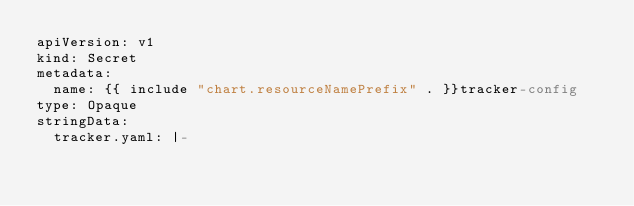Convert code to text. <code><loc_0><loc_0><loc_500><loc_500><_YAML_>apiVersion: v1
kind: Secret
metadata:
  name: {{ include "chart.resourceNamePrefix" . }}tracker-config
type: Opaque
stringData:
  tracker.yaml: |-</code> 